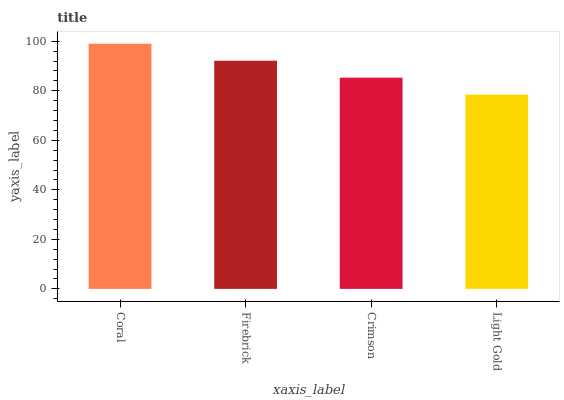Is Light Gold the minimum?
Answer yes or no. Yes. Is Coral the maximum?
Answer yes or no. Yes. Is Firebrick the minimum?
Answer yes or no. No. Is Firebrick the maximum?
Answer yes or no. No. Is Coral greater than Firebrick?
Answer yes or no. Yes. Is Firebrick less than Coral?
Answer yes or no. Yes. Is Firebrick greater than Coral?
Answer yes or no. No. Is Coral less than Firebrick?
Answer yes or no. No. Is Firebrick the high median?
Answer yes or no. Yes. Is Crimson the low median?
Answer yes or no. Yes. Is Light Gold the high median?
Answer yes or no. No. Is Firebrick the low median?
Answer yes or no. No. 